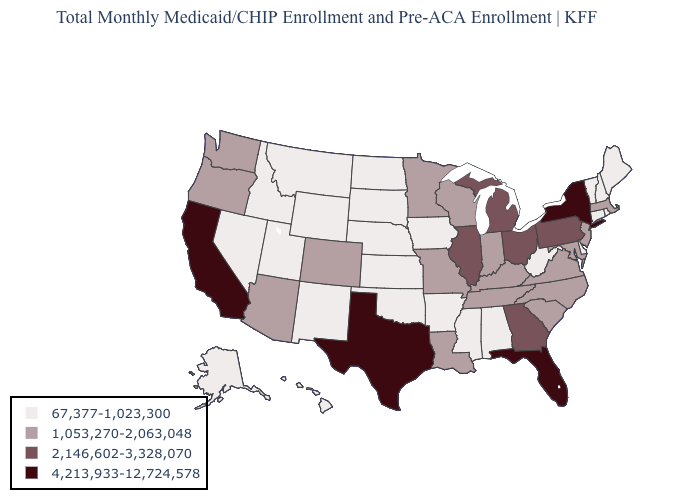Name the states that have a value in the range 2,146,602-3,328,070?
Quick response, please. Georgia, Illinois, Michigan, Ohio, Pennsylvania. How many symbols are there in the legend?
Give a very brief answer. 4. How many symbols are there in the legend?
Write a very short answer. 4. Which states have the highest value in the USA?
Concise answer only. California, Florida, New York, Texas. Among the states that border New Mexico , does Texas have the highest value?
Quick response, please. Yes. Which states have the highest value in the USA?
Keep it brief. California, Florida, New York, Texas. Does Massachusetts have the same value as Pennsylvania?
Give a very brief answer. No. Does Arizona have the same value as New Jersey?
Quick response, please. Yes. Does Michigan have the highest value in the MidWest?
Short answer required. Yes. How many symbols are there in the legend?
Quick response, please. 4. Name the states that have a value in the range 1,053,270-2,063,048?
Be succinct. Arizona, Colorado, Indiana, Kentucky, Louisiana, Maryland, Massachusetts, Minnesota, Missouri, New Jersey, North Carolina, Oregon, South Carolina, Tennessee, Virginia, Washington, Wisconsin. Name the states that have a value in the range 67,377-1,023,300?
Give a very brief answer. Alabama, Alaska, Arkansas, Connecticut, Delaware, Hawaii, Idaho, Iowa, Kansas, Maine, Mississippi, Montana, Nebraska, Nevada, New Hampshire, New Mexico, North Dakota, Oklahoma, Rhode Island, South Dakota, Utah, Vermont, West Virginia, Wyoming. What is the value of Wyoming?
Write a very short answer. 67,377-1,023,300. What is the highest value in states that border Georgia?
Be succinct. 4,213,933-12,724,578. What is the value of Pennsylvania?
Answer briefly. 2,146,602-3,328,070. 